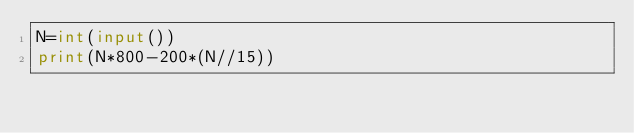<code> <loc_0><loc_0><loc_500><loc_500><_Python_>N=int(input())
print(N*800-200*(N//15))</code> 